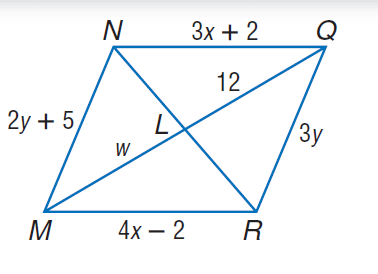Question: Use parallelogram N Q R M to find w.
Choices:
A. 4
B. 12
C. 14
D. 29
Answer with the letter. Answer: B Question: Use parallelogram N Q R M to find N Q.
Choices:
A. 13
B. 14
C. 15
D. 16
Answer with the letter. Answer: B Question: Use parallelogram N Q R M to find Q R.
Choices:
A. 13
B. 14
C. 15
D. 16
Answer with the letter. Answer: C Question: Use parallelogram N Q R M to find x.
Choices:
A. 4
B. 12
C. 14
D. 29
Answer with the letter. Answer: A 